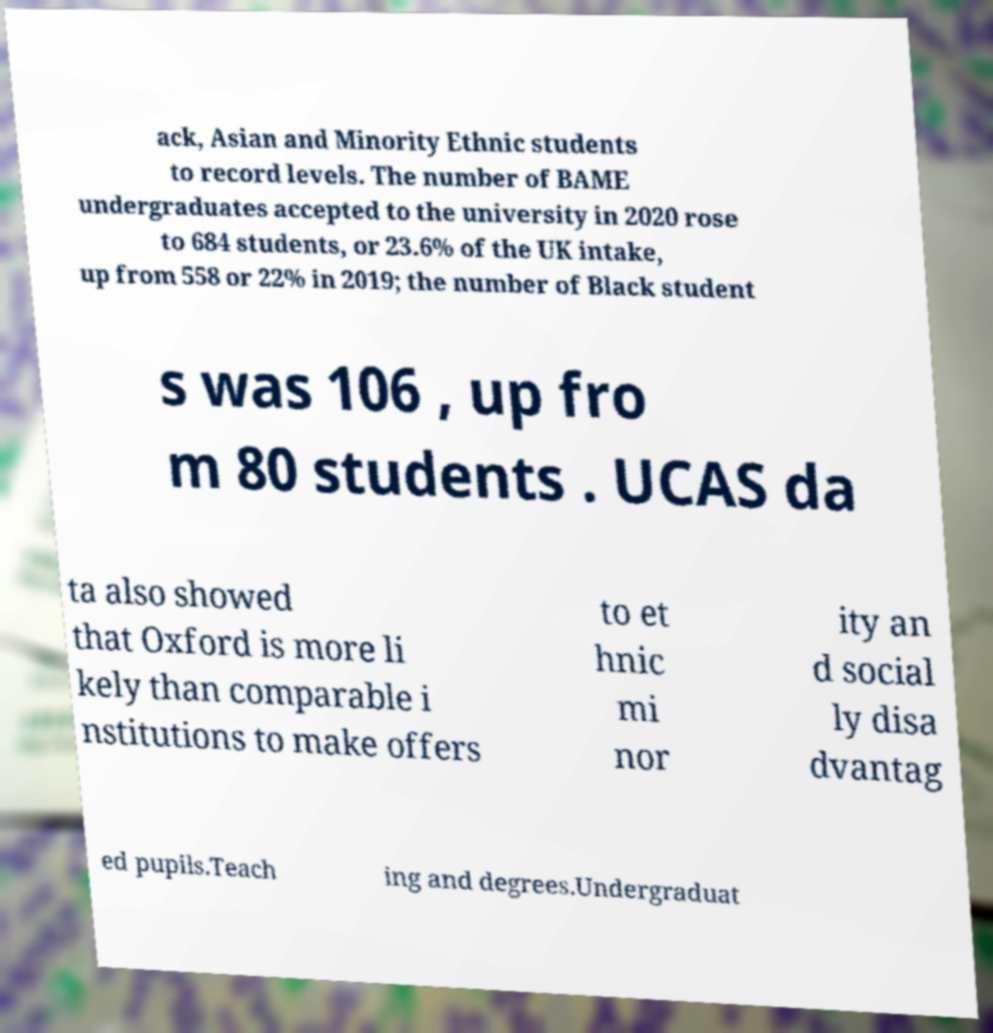Could you assist in decoding the text presented in this image and type it out clearly? ack, Asian and Minority Ethnic students to record levels. The number of BAME undergraduates accepted to the university in 2020 rose to 684 students, or 23.6% of the UK intake, up from 558 or 22% in 2019; the number of Black student s was 106 , up fro m 80 students . UCAS da ta also showed that Oxford is more li kely than comparable i nstitutions to make offers to et hnic mi nor ity an d social ly disa dvantag ed pupils.Teach ing and degrees.Undergraduat 